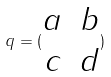Convert formula to latex. <formula><loc_0><loc_0><loc_500><loc_500>q = ( \begin{matrix} a & b \\ c & d \end{matrix} )</formula> 